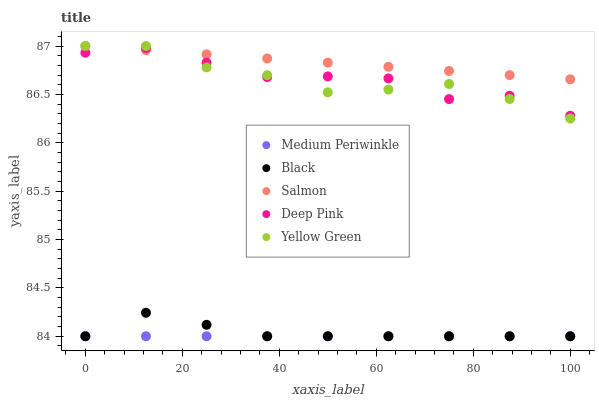Does Medium Periwinkle have the minimum area under the curve?
Answer yes or no. Yes. Does Salmon have the maximum area under the curve?
Answer yes or no. Yes. Does Deep Pink have the minimum area under the curve?
Answer yes or no. No. Does Deep Pink have the maximum area under the curve?
Answer yes or no. No. Is Medium Periwinkle the smoothest?
Answer yes or no. Yes. Is Deep Pink the roughest?
Answer yes or no. Yes. Is Deep Pink the smoothest?
Answer yes or no. No. Is Medium Periwinkle the roughest?
Answer yes or no. No. Does Black have the lowest value?
Answer yes or no. Yes. Does Deep Pink have the lowest value?
Answer yes or no. No. Does Salmon have the highest value?
Answer yes or no. Yes. Does Deep Pink have the highest value?
Answer yes or no. No. Is Medium Periwinkle less than Salmon?
Answer yes or no. Yes. Is Deep Pink greater than Medium Periwinkle?
Answer yes or no. Yes. Does Yellow Green intersect Salmon?
Answer yes or no. Yes. Is Yellow Green less than Salmon?
Answer yes or no. No. Is Yellow Green greater than Salmon?
Answer yes or no. No. Does Medium Periwinkle intersect Salmon?
Answer yes or no. No. 